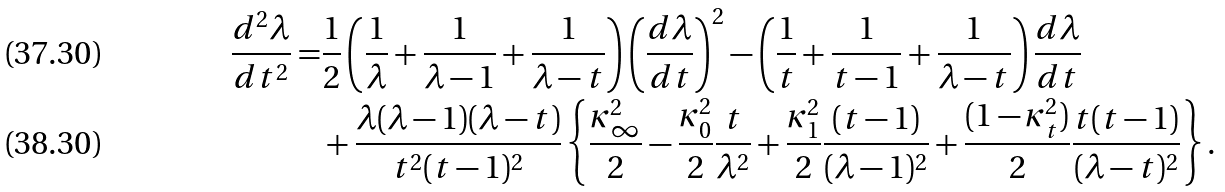Convert formula to latex. <formula><loc_0><loc_0><loc_500><loc_500>\frac { d ^ { 2 } \lambda } { d t ^ { 2 } } = & \frac { 1 } { 2 } \left ( \frac { 1 } { \lambda } + \frac { 1 } { \lambda - 1 } + \frac { 1 } { \lambda - t } \right ) \left ( \frac { d \lambda } { d t } \right ) ^ { 2 } - \left ( \frac { 1 } { t } + \frac { 1 } { t - 1 } + \frac { 1 } { \lambda - t } \right ) \frac { d \lambda } { d t } \\ & + \frac { \lambda ( \lambda - 1 ) ( \lambda - t ) } { t ^ { 2 } ( t - 1 ) ^ { 2 } } \left \{ \frac { \kappa _ { \infty } ^ { 2 } } { 2 } - \frac { \kappa _ { 0 } ^ { 2 } } { 2 } \frac { t } { \lambda ^ { 2 } } + \frac { \kappa _ { 1 } ^ { 2 } } { 2 } \frac { ( t - 1 ) } { ( \lambda - 1 ) ^ { 2 } } + \frac { ( 1 - \kappa _ { t } ^ { 2 } ) } { 2 } \frac { t ( t - 1 ) } { ( \lambda - t ) ^ { 2 } } \right \} .</formula> 